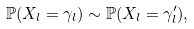<formula> <loc_0><loc_0><loc_500><loc_500>\mathbb { P } ( X _ { l } = \gamma _ { l } ) \sim \mathbb { P } ( X _ { l } = \gamma _ { l } ^ { \prime } ) ,</formula> 